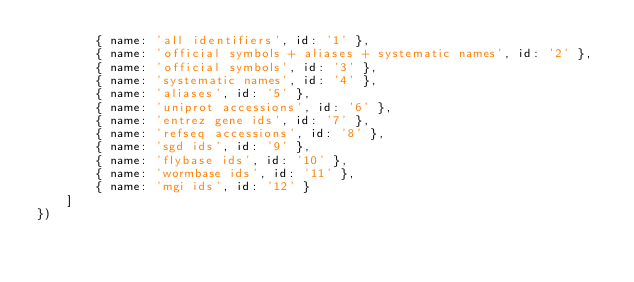<code> <loc_0><loc_0><loc_500><loc_500><_JavaScript_>        { name: 'all identifiers', id: '1' },
        { name: 'official symbols + aliases + systematic names', id: '2' },
        { name: 'official symbols', id: '3' },
        { name: 'systematic names', id: '4' },
        { name: 'aliases', id: '5' },
        { name: 'uniprot accessions', id: '6' },
        { name: 'entrez gene ids', id: '7' },
        { name: 'refseq accessions', id: '8' },
        { name: 'sgd ids', id: '9' },
        { name: 'flybase ids', id: '10' },
        { name: 'wormbase ids', id: '11' },
        { name: 'mgi ids', id: '12' }
    ]
})
</code> 